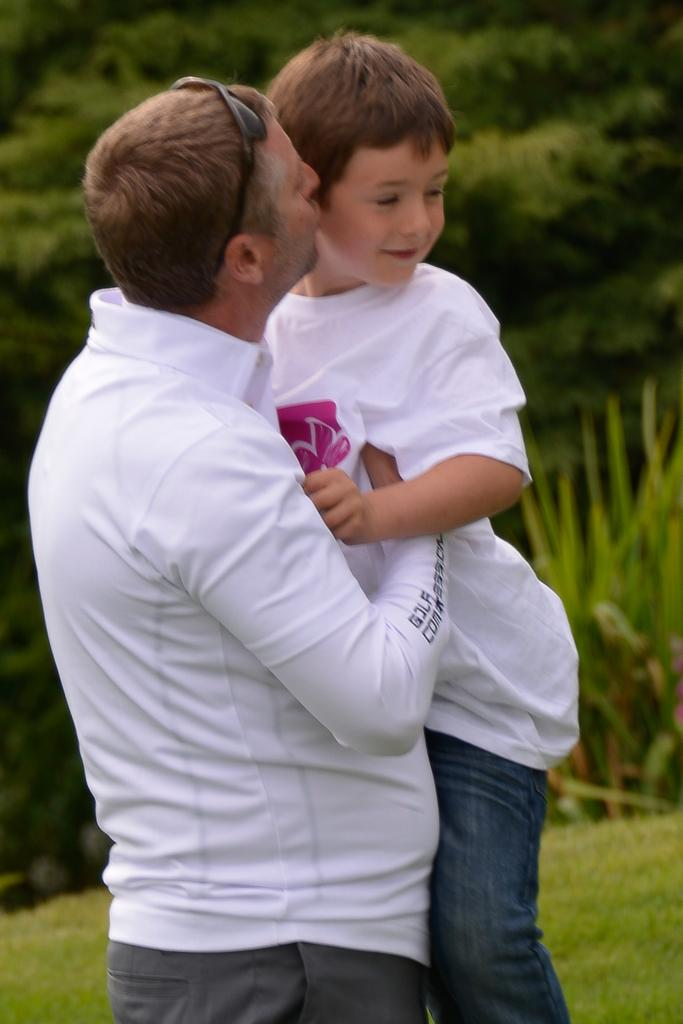What is happening in the image involving the man and the boy? The man is carrying the boy and kissing him. What can be seen in the background of the image? There are trees, plants, and grass in the background of the image. What type of fruit is growing in the hole in the image? There is no hole or fruit present in the image. 